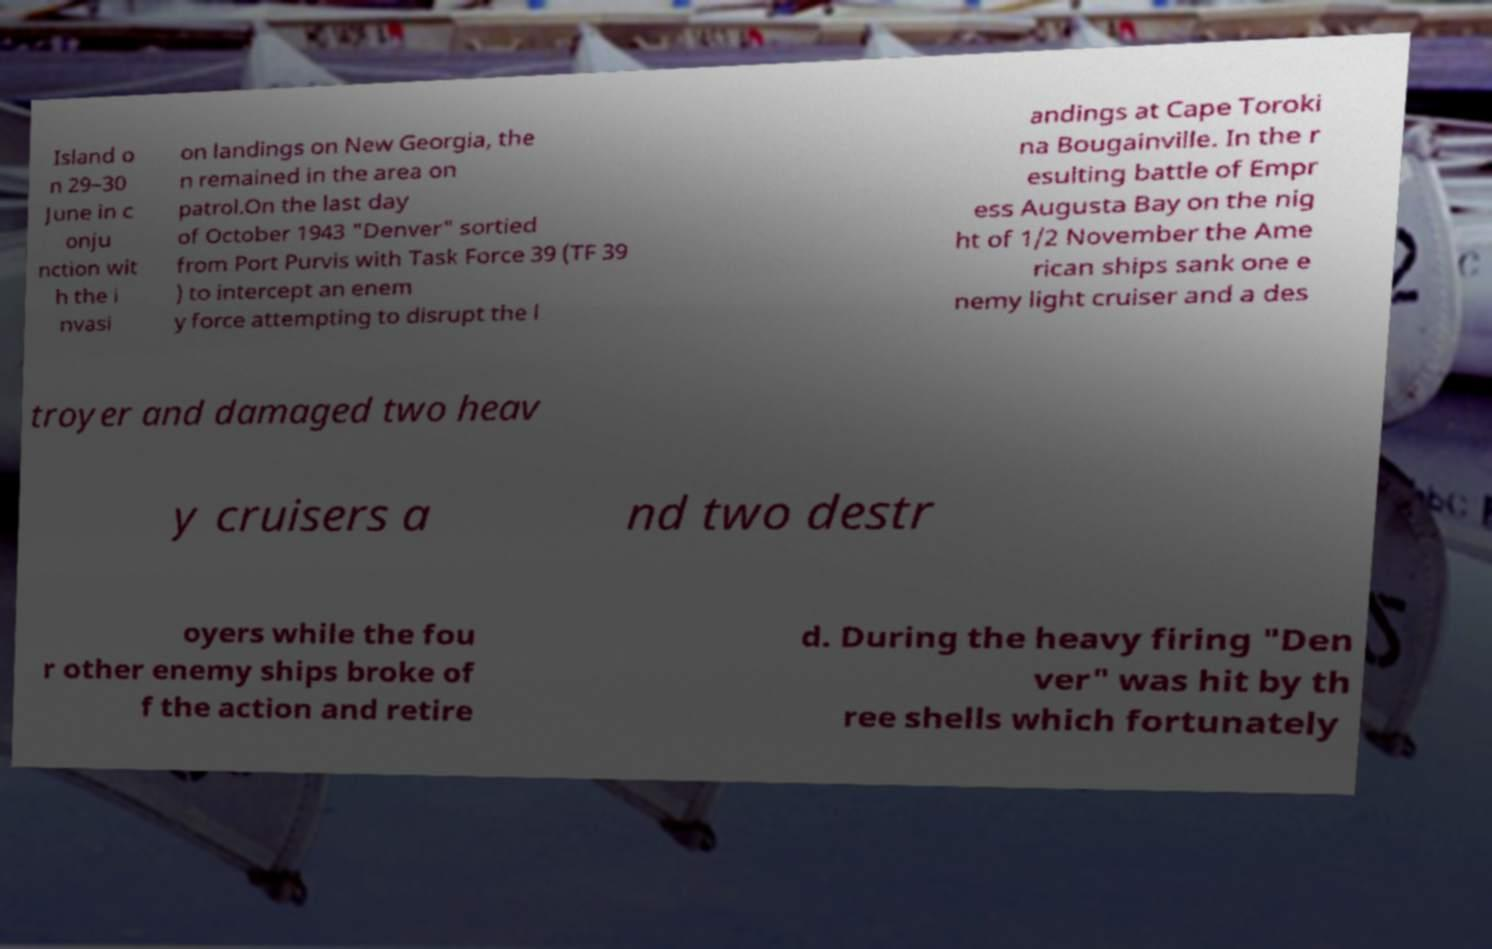Please read and relay the text visible in this image. What does it say? Island o n 29–30 June in c onju nction wit h the i nvasi on landings on New Georgia, the n remained in the area on patrol.On the last day of October 1943 "Denver" sortied from Port Purvis with Task Force 39 (TF 39 ) to intercept an enem y force attempting to disrupt the l andings at Cape Toroki na Bougainville. In the r esulting battle of Empr ess Augusta Bay on the nig ht of 1/2 November the Ame rican ships sank one e nemy light cruiser and a des troyer and damaged two heav y cruisers a nd two destr oyers while the fou r other enemy ships broke of f the action and retire d. During the heavy firing "Den ver" was hit by th ree shells which fortunately 